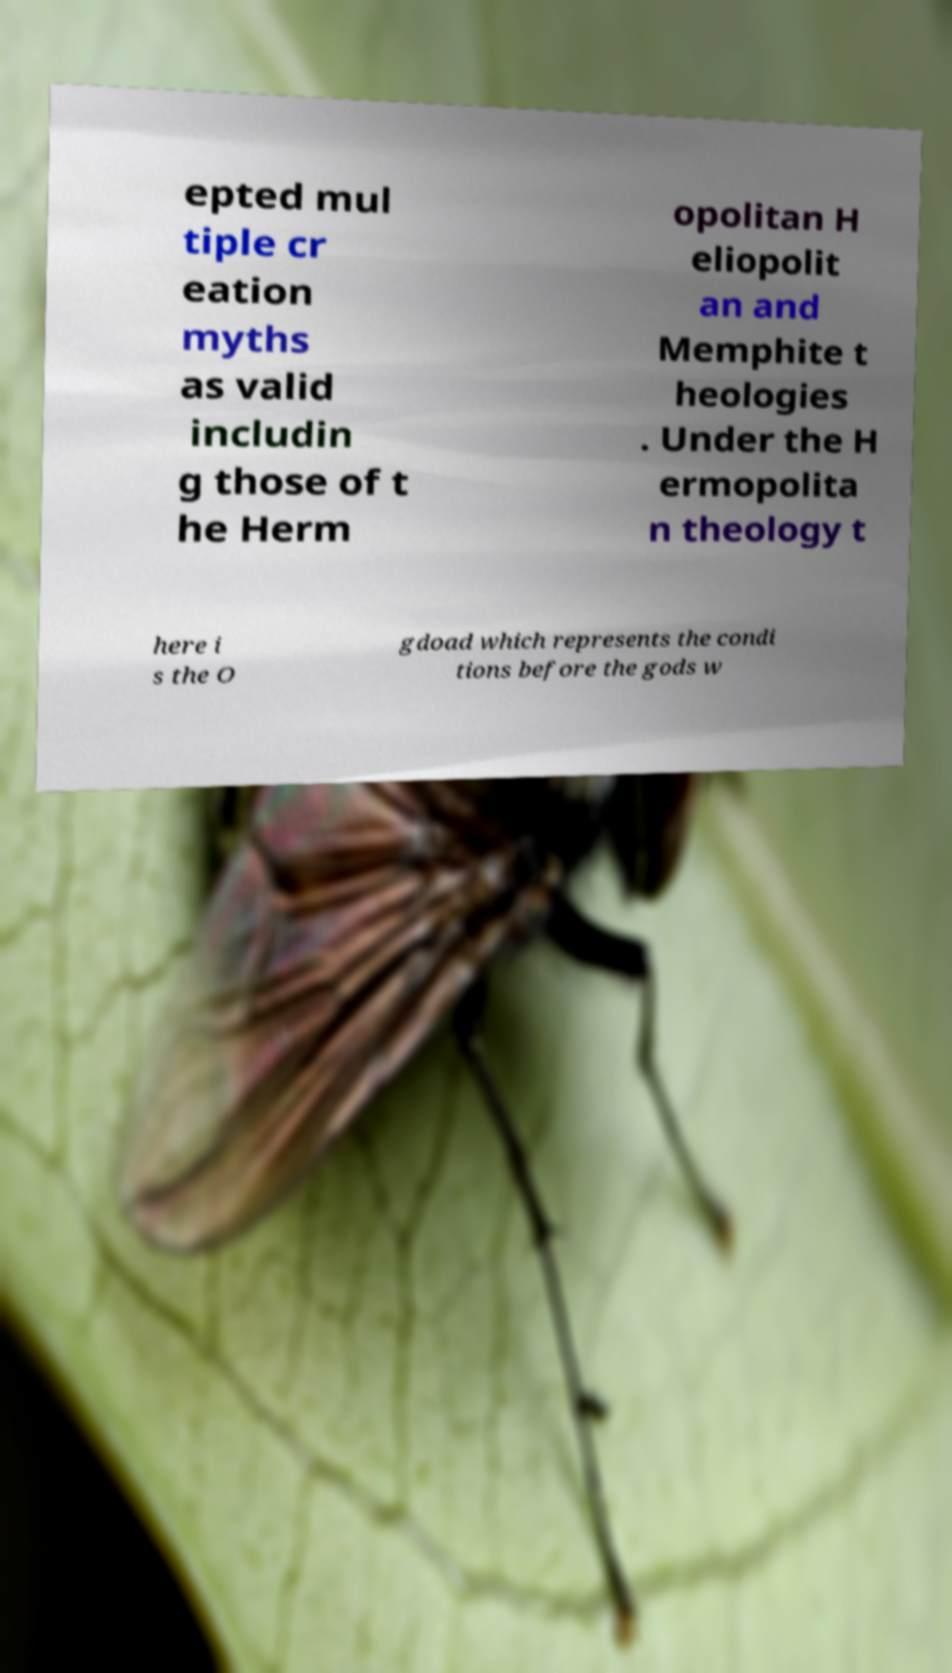For documentation purposes, I need the text within this image transcribed. Could you provide that? epted mul tiple cr eation myths as valid includin g those of t he Herm opolitan H eliopolit an and Memphite t heologies . Under the H ermopolita n theology t here i s the O gdoad which represents the condi tions before the gods w 